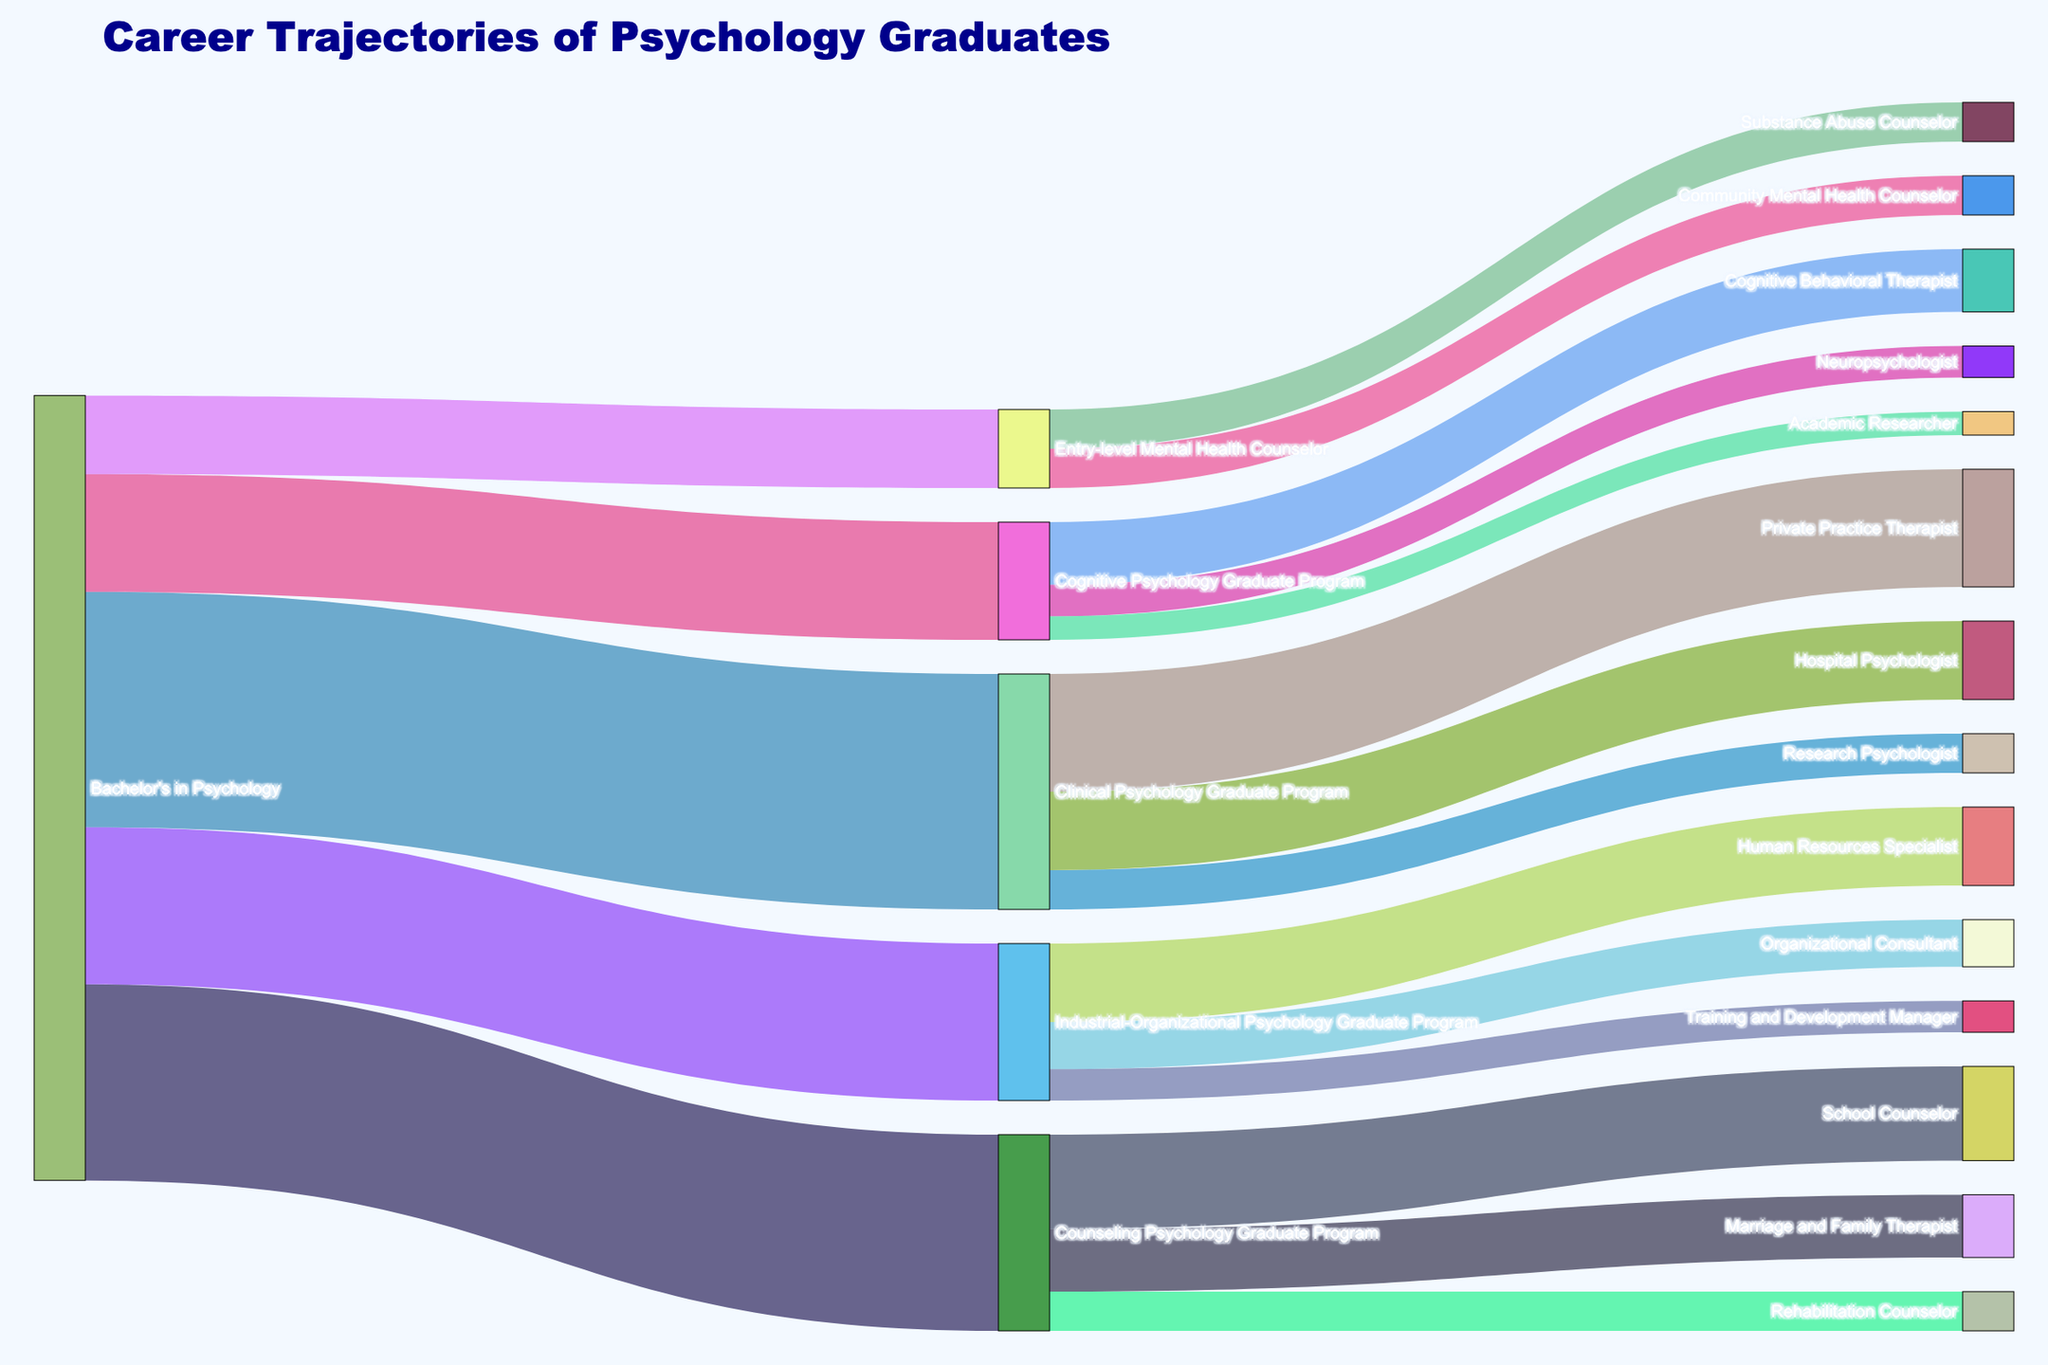How many graduates from the Clinical Psychology Graduate Program become Private Practice Therapists? Look at the flow from the Clinical Psychology Graduate Program to Private Practice Therapist and note the value associated with that link.
Answer: 15 What is the total number of graduates who enter Counseling Psychology Graduate Program? Sum the flows from the Bachelor's in Psychology to the Counseling Psychology Graduate Program. The value is given directly.
Answer: 25 Which specialization has the highest number of graduates from the Bachelor's in Psychology? Compare the values of different direct flows from the Bachelor's in Psychology to various specializations.
Answer: Clinical Psychology Graduate Program How many graduates move from Entry-level Mental Health Counselor positions to Substance Abuse Counselor positions? Identify the flow from Entry-level Mental Health Counselor to Substance Abuse Counselor and note the value.
Answer: 5 Compare the number of graduates who become School Counselors versus those who become Marriage and Family Therapists after finishing the Counseling Psychology Graduate Program. Look at the flows from the Counseling Psychology Graduate Program to School Counselor and Marriage and Family Therapist and compare their values.
Answer: School Counselors: 12, Marriage and Family Therapists: 8 Which end specialization after the Industrial-Organizational Psychology Graduate Program has the least number of graduates? Compare the values of the end specializations for the Industrial-Organizational Psychology Graduate Program and identify the smallest number.
Answer: Training and Development Manager What is the total number of graduates who progress from initial Bachelor's in Psychology to any type of Mental Health Counseling role, including all detailed specializations? Sum the flows from Bachelor's in Psychology to Entry-level Mental Health Counselor, and from Entry-level Mental Health Counselor to its respective specializations.
Answer: 10 + 5 + 5 = 20 Identify the specialization with the smallest number of graduates who complete a Cognitive Psychology Graduate Program. Compare the values of the end specializations for the Cognitive Psychology Graduate Program and identify the smallest number.
Answer: Academic Researcher How many graduates from the Industrial-Organizational Psychology Graduate Program become Human Resources Specialists compared to Organizational Consultants? Look at the flows from the Industrial-Organizational Psychology Graduate Program to Human Resources Specialist and Organizational Consultant and note their values for comparison.
Answer: Human Resources Specialists: 10, Organizational Consultants: 6 